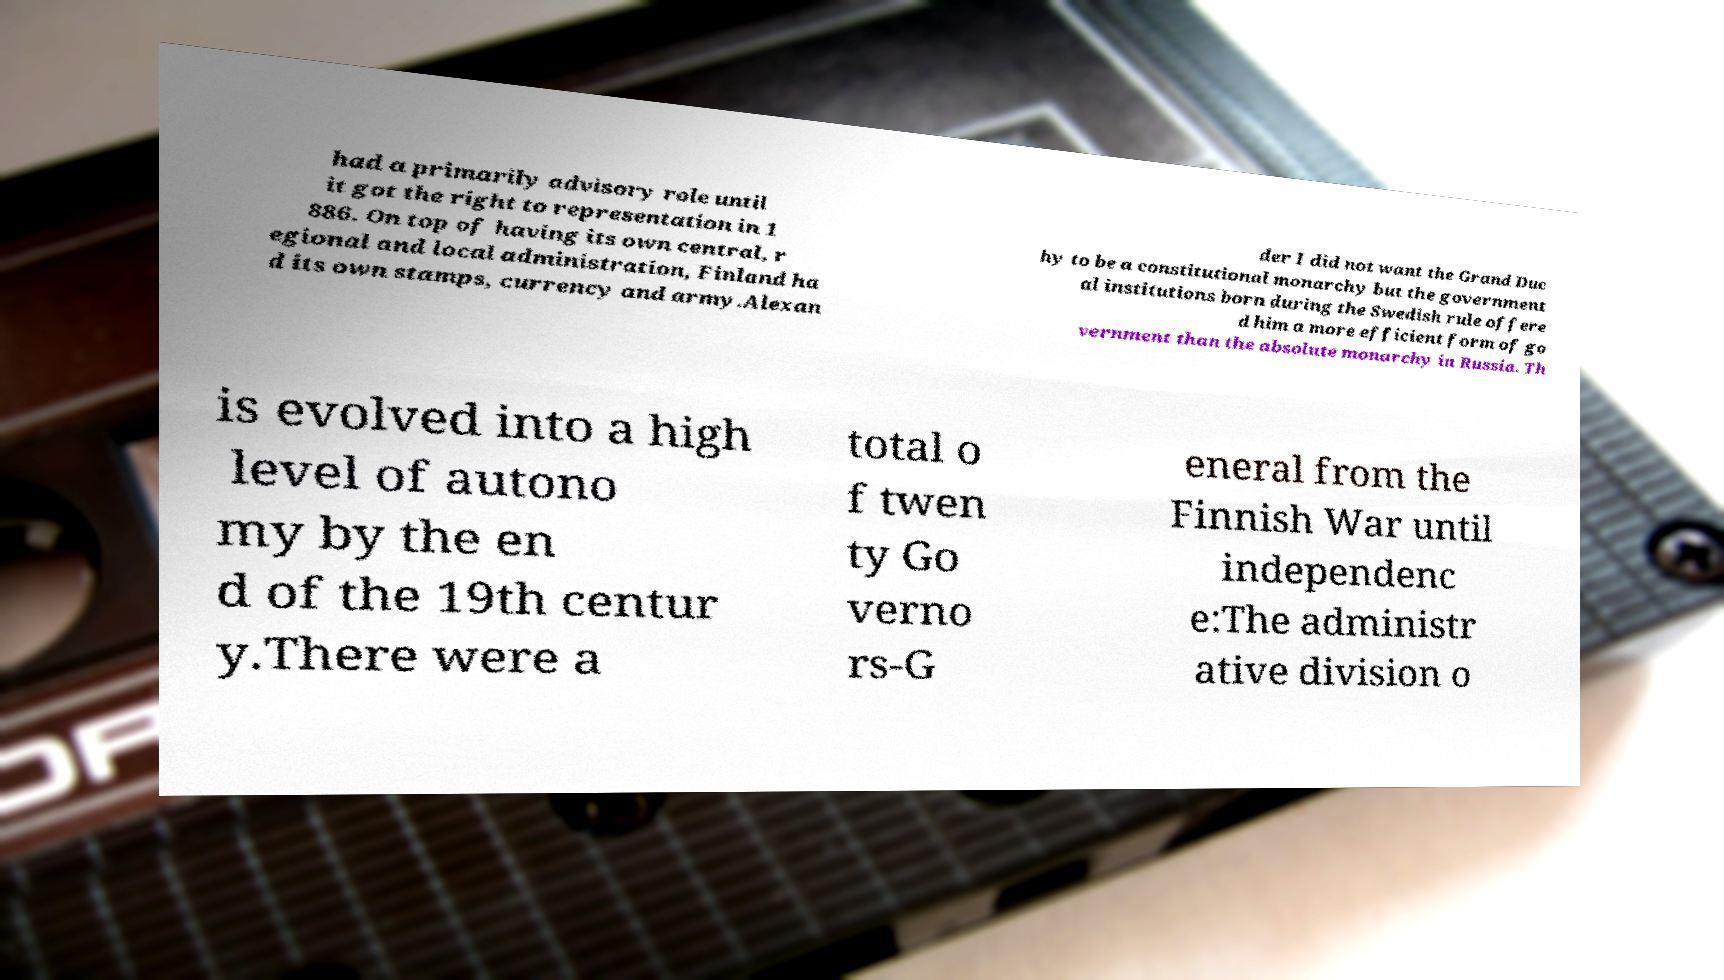Can you read and provide the text displayed in the image?This photo seems to have some interesting text. Can you extract and type it out for me? had a primarily advisory role until it got the right to representation in 1 886. On top of having its own central, r egional and local administration, Finland ha d its own stamps, currency and army.Alexan der I did not want the Grand Duc hy to be a constitutional monarchy but the government al institutions born during the Swedish rule offere d him a more efficient form of go vernment than the absolute monarchy in Russia. Th is evolved into a high level of autono my by the en d of the 19th centur y.There were a total o f twen ty Go verno rs-G eneral from the Finnish War until independenc e:The administr ative division o 